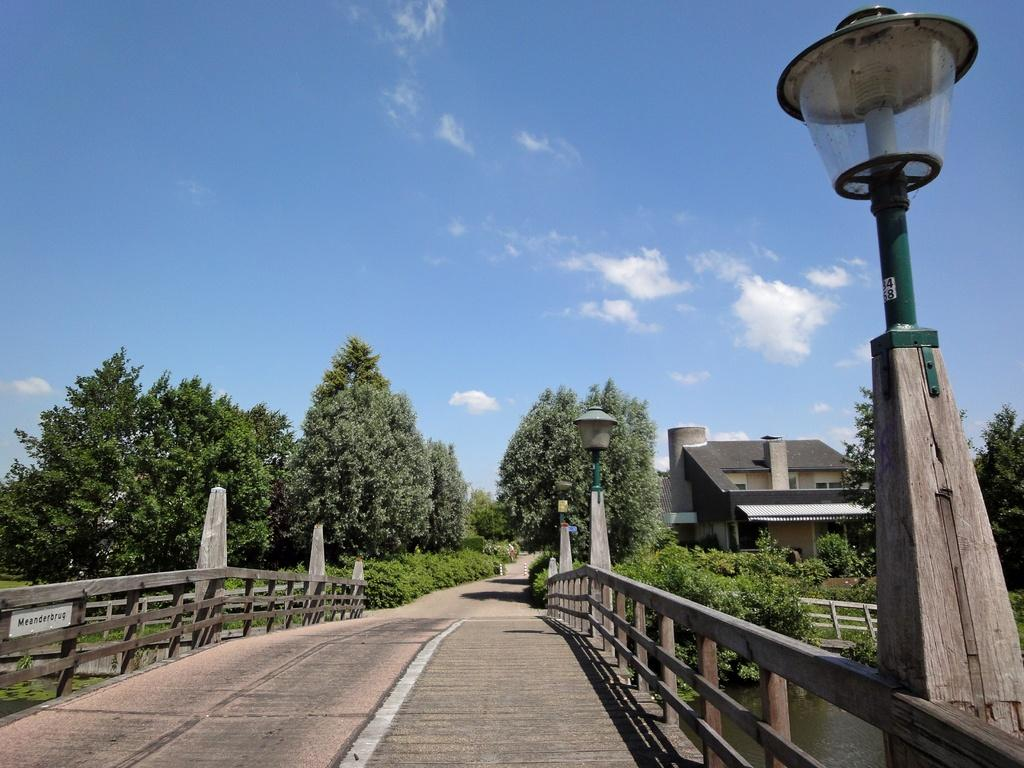What type of structure is present in the image? There is a wooden bridge in the image. What can be seen illuminating the scene in the image? There are lights in the image. What natural element is visible in the image? There is water visible in the image. What type of man-made structure is present in the image? There is a building in the image. What type of vegetation is present in the image? There are trees in the image. What is visible in the background of the image? The sky is visible in the background of the image. What is the price of the wooden bridge in the image? There is no price mentioned or implied in the image, as it is a photograph and not a sales advertisement. What type of war is depicted in the image? There is no war or any indication of conflict in the image; it features a wooden bridge, lights, water, a building, trees, and the sky. 